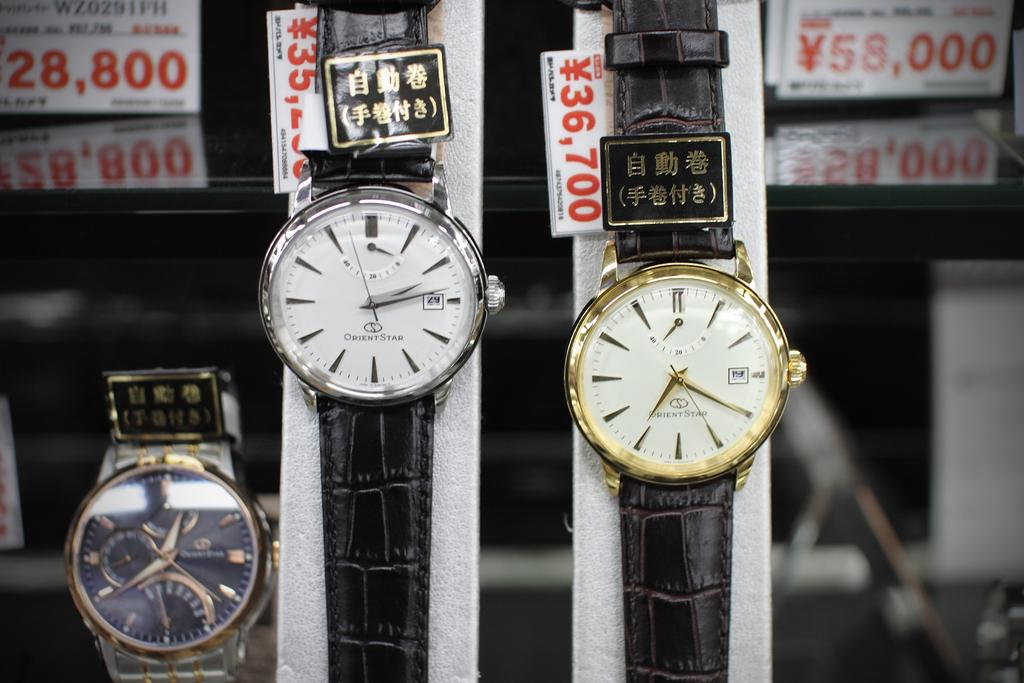<image>
Offer a succinct explanation of the picture presented. Orient Star watches are hanging on a display. 